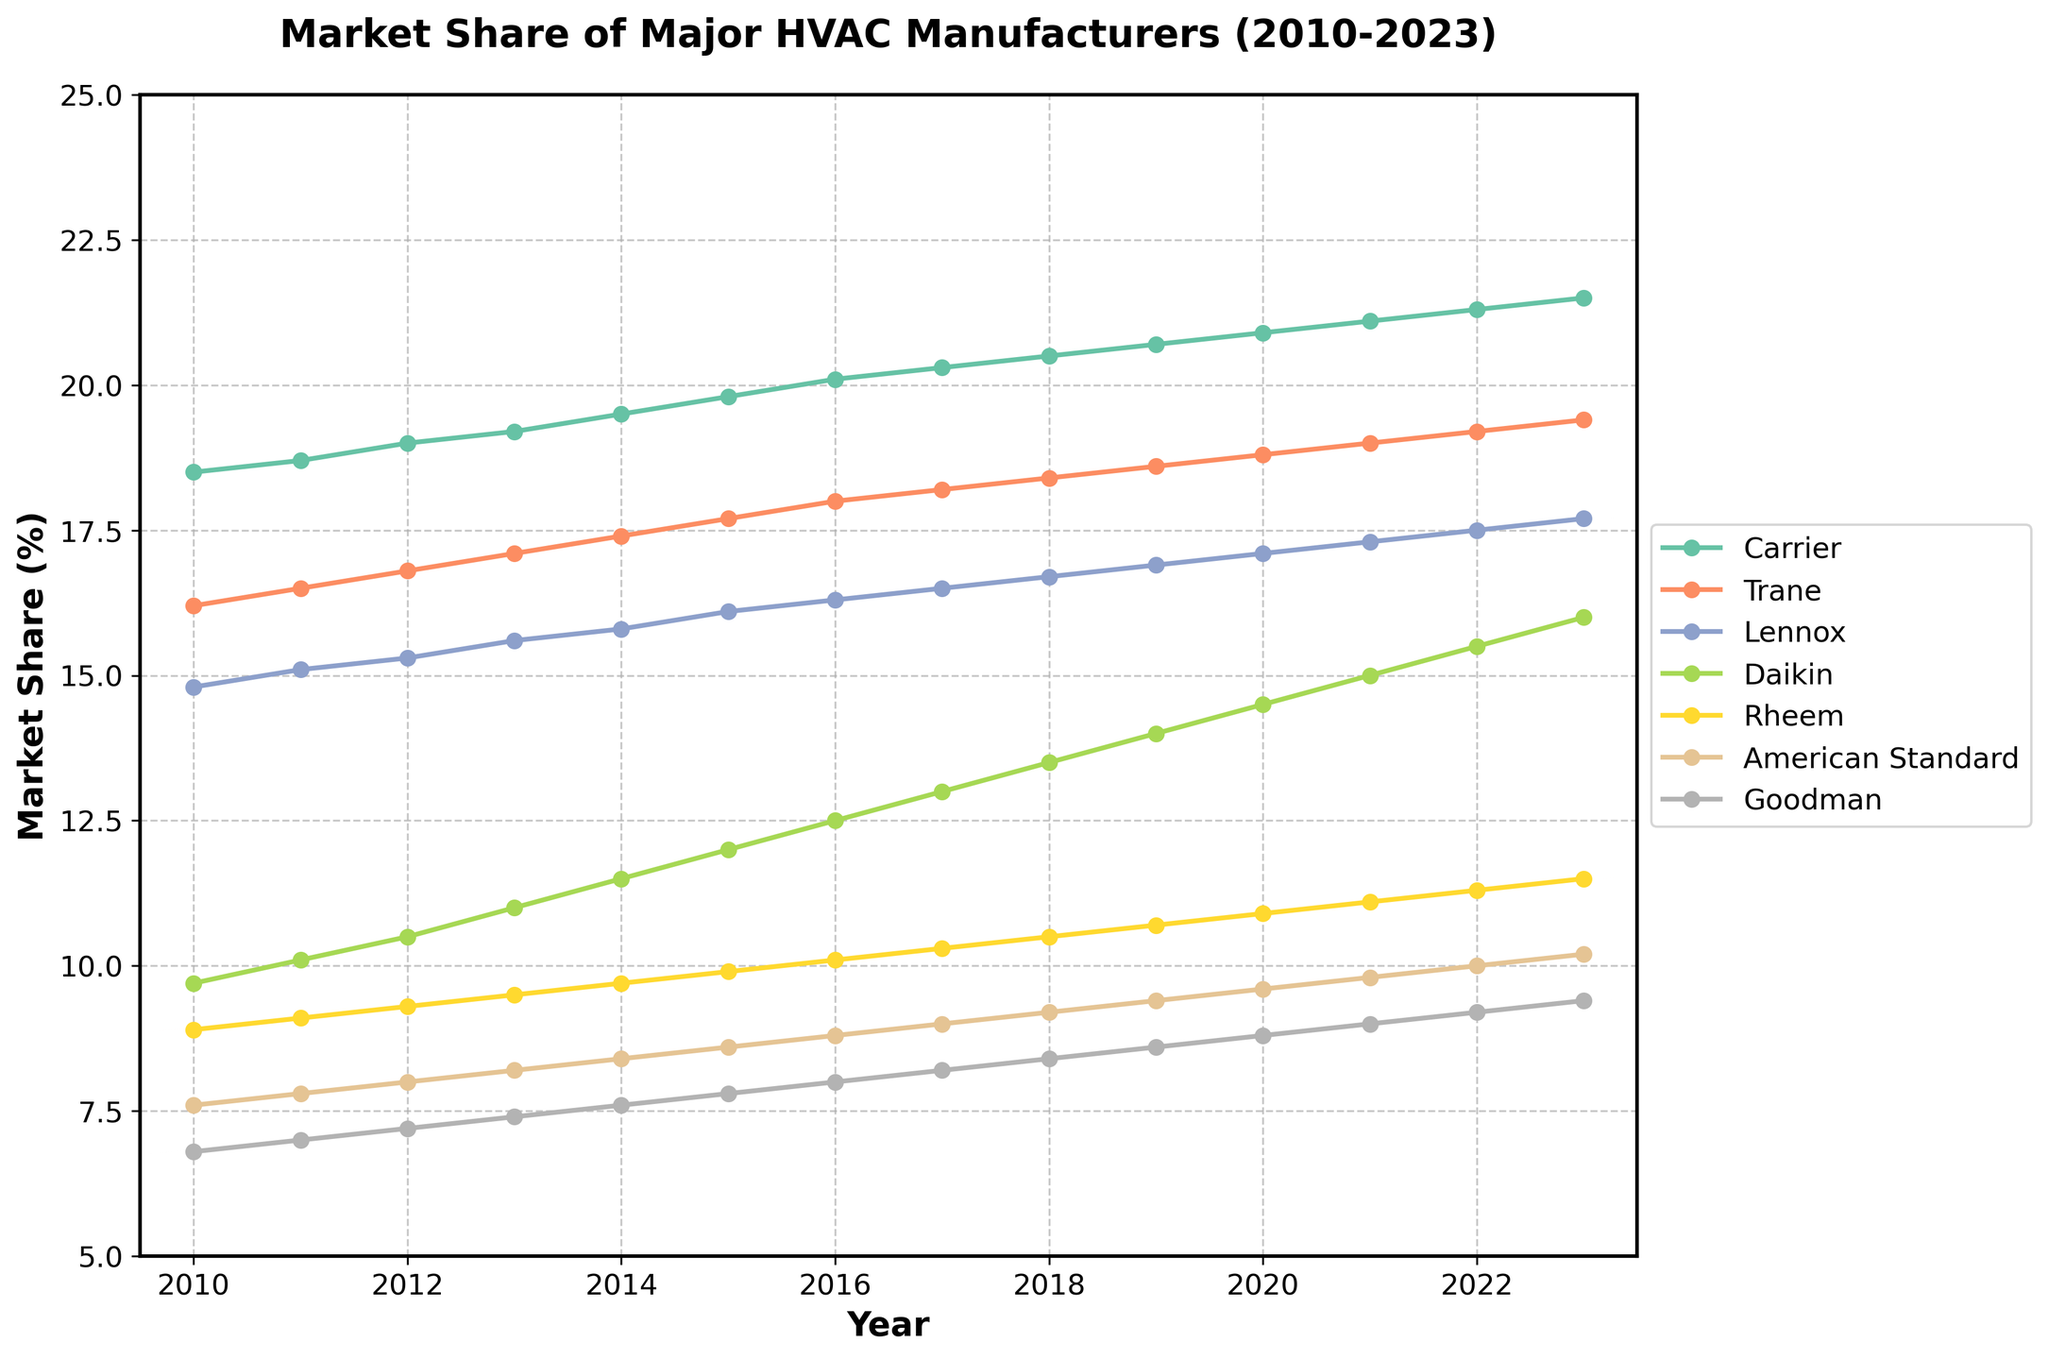What's the market share trend for Carrier from 2010 to 2023? By observing the line representing Carrier, we see that it starts at 18.5% in 2010 and gradually increases to 21.5% in 2023. This indicates a positive trend in Carrier's market share over these years.
Answer: Increasing Which manufacturer had the second-highest market share in 2020? Looking at the 2020 data points, we observe that Trane had the second-highest market share with 18.8%, just below Carrier.
Answer: Trane Between which years did Daikin's market share increase the most? Daikin's market share saw a significant increase between 2013 and 2014, jumping from 11.0% to 11.5%.
Answer: 2013 to 2014 By how much did Lennox's market share change from 2010 to 2023? The starting market share for Lennox in 2010 was 14.8%, and by 2023 it had increased to 17.7%. The change is calculated as 17.7% - 14.8% = 2.9%.
Answer: 2.9% Which manufacturer had the smallest market share in 2015, and what was it? By observing the data in 2015, Goodman had the smallest market share at 7.8%.
Answer: Goodman, 7.8% In which year did Rheem surpass 10% market share for the first time? Rheem's market share first surpassed 10% in 2016, where it increased to 10.1%.
Answer: 2016 How does the average market share of American Standard from 2010 to 2023 compare to that of Rheem? The average market share is calculated by summing up each year's value and dividing by the number of years (14). American Standard's total is 139.4, so its average is 139.4/14 = 9.96. Rheem's total is 149.8, so its average is 149.8/14 = 10.7. Rheem has a higher average market share.
Answer: American Standard: 9.96, Rheem: 10.7 Which manufacturer showed the most consistent increase in market share over the years? Carrier's market share increased steadily from 18.5% in 2010 to 21.5% in 2023, showing the most consistent growth pattern with no dips.
Answer: Carrier Which year had the smallest combined market share of Trane and Goodman? Adding the market shares of Trane and Goodman for each year, we find that the smallest combined share is in 2010, with 16.2% + 6.8% = 23.0%.
Answer: 2010 What was the market share difference between Carrier and Goodman in 2023? Carrier's market share in 2023 was 21.5%, and Goodman's was 9.4%. The difference is 21.5% - 9.4% = 12.1%.
Answer: 12.1% 